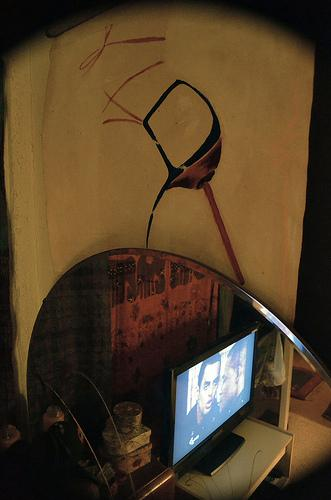Question: where was the picture taken?
Choices:
A. At a hospital.
B. At a gas station.
C. In a living room.
D. Under water.
Answer with the letter. Answer: C Question: what is under the arch?
Choices:
A. The radio.
B. The television.
C. The cup.
D. The pet fish.
Answer with the letter. Answer: B Question: what color is the wall?
Choices:
A. Yellow.
B. Blue.
C. Red.
D. White.
Answer with the letter. Answer: D Question: where is the television?
Choices:
A. On the table.
B. Under the arch.
C. Hanging on the wall.
D. In the store.
Answer with the letter. Answer: B 